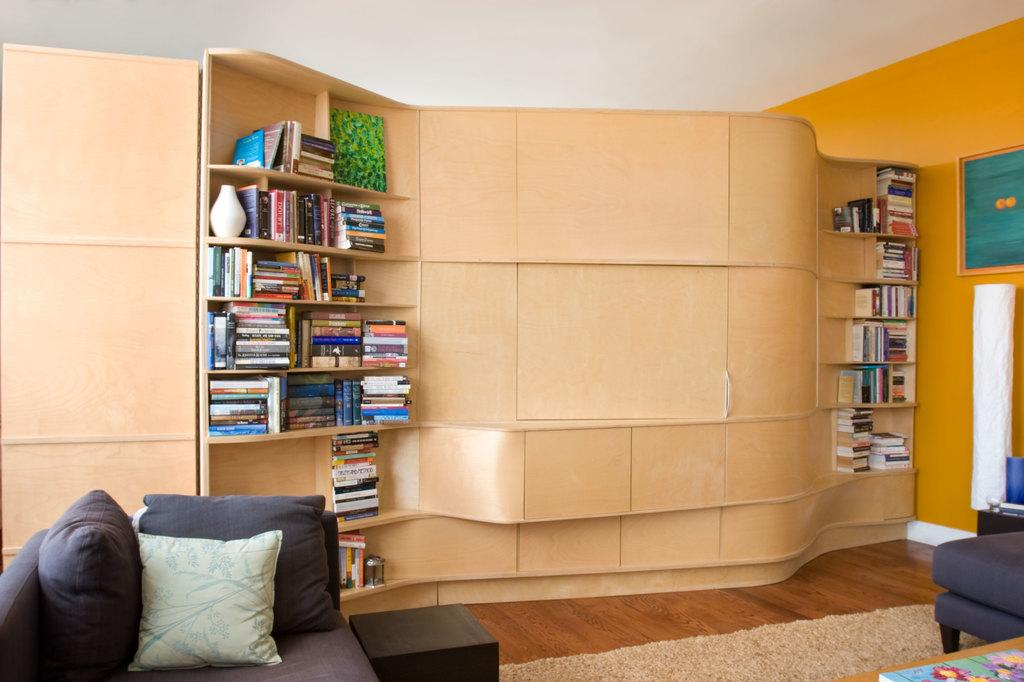What type of space is depicted in the image? The image shows a room. What furniture can be seen in the room? There is a bookshelf and a sofa bed in the room. What type of haircut does the bookshelf have in the image? The bookshelf does not have a haircut, as it is an inanimate object and cannot have a haircut. 